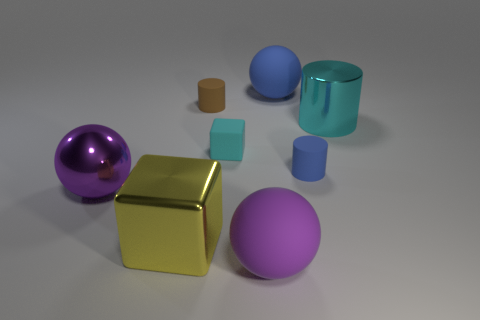What is the material of the big thing that is to the left of the tiny cyan thing and behind the large yellow cube?
Keep it short and to the point. Metal. Does the large sphere behind the blue rubber cylinder have the same color as the small cylinder that is in front of the tiny matte block?
Ensure brevity in your answer.  Yes. How many other objects are there of the same size as the shiny cylinder?
Your response must be concise. 4. Are there any rubber balls that are in front of the big purple sphere that is to the left of the large matte thing that is in front of the metallic cylinder?
Your answer should be very brief. Yes. Does the cyan thing that is on the right side of the big purple matte sphere have the same material as the brown thing?
Provide a short and direct response. No. What color is the shiny thing that is the same shape as the big purple matte object?
Make the answer very short. Purple. Are there an equal number of big balls that are right of the metallic ball and small green blocks?
Offer a terse response. No. There is a cyan cylinder; are there any big cyan cylinders behind it?
Make the answer very short. No. What size is the cyan thing in front of the object on the right side of the blue cylinder in front of the cyan metal object?
Your response must be concise. Small. Is the shape of the blue thing behind the brown cylinder the same as the metal object that is to the right of the small brown thing?
Ensure brevity in your answer.  No. 